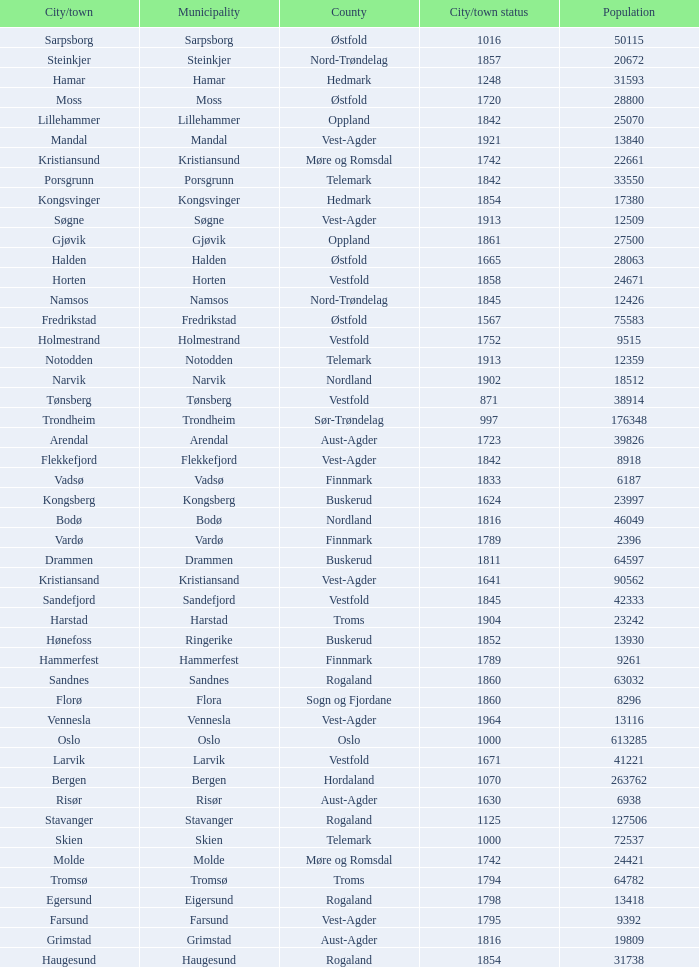What are the cities/towns located in the municipality of Moss? Moss. 